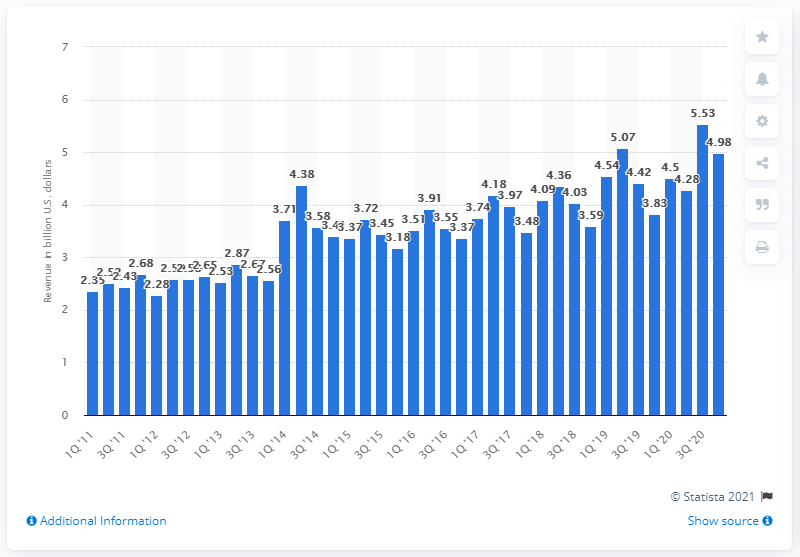Highlight a few significant elements in this photo. LG Electronics' revenue from home appliances and air solutions in the fourth quarter of 2020 was 4.98 billion. 